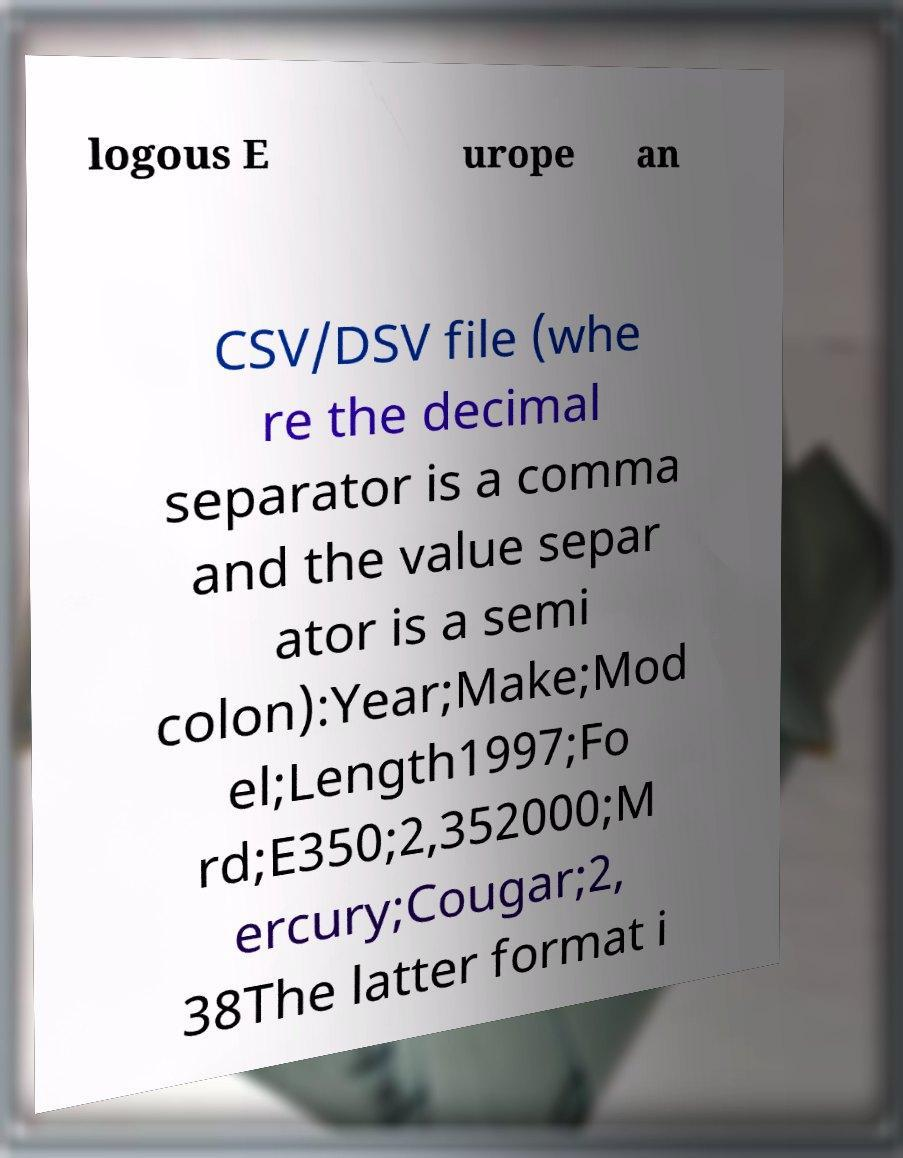There's text embedded in this image that I need extracted. Can you transcribe it verbatim? logous E urope an CSV/DSV file (whe re the decimal separator is a comma and the value separ ator is a semi colon):Year;Make;Mod el;Length1997;Fo rd;E350;2,352000;M ercury;Cougar;2, 38The latter format i 